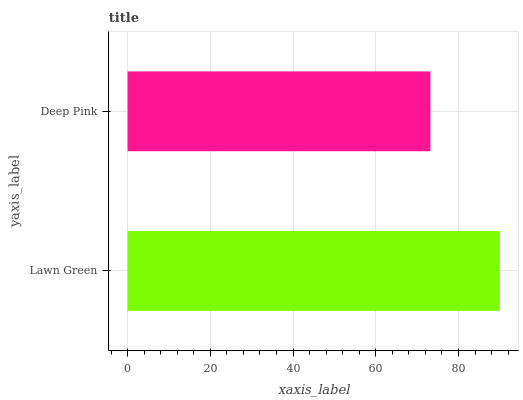Is Deep Pink the minimum?
Answer yes or no. Yes. Is Lawn Green the maximum?
Answer yes or no. Yes. Is Deep Pink the maximum?
Answer yes or no. No. Is Lawn Green greater than Deep Pink?
Answer yes or no. Yes. Is Deep Pink less than Lawn Green?
Answer yes or no. Yes. Is Deep Pink greater than Lawn Green?
Answer yes or no. No. Is Lawn Green less than Deep Pink?
Answer yes or no. No. Is Lawn Green the high median?
Answer yes or no. Yes. Is Deep Pink the low median?
Answer yes or no. Yes. Is Deep Pink the high median?
Answer yes or no. No. Is Lawn Green the low median?
Answer yes or no. No. 